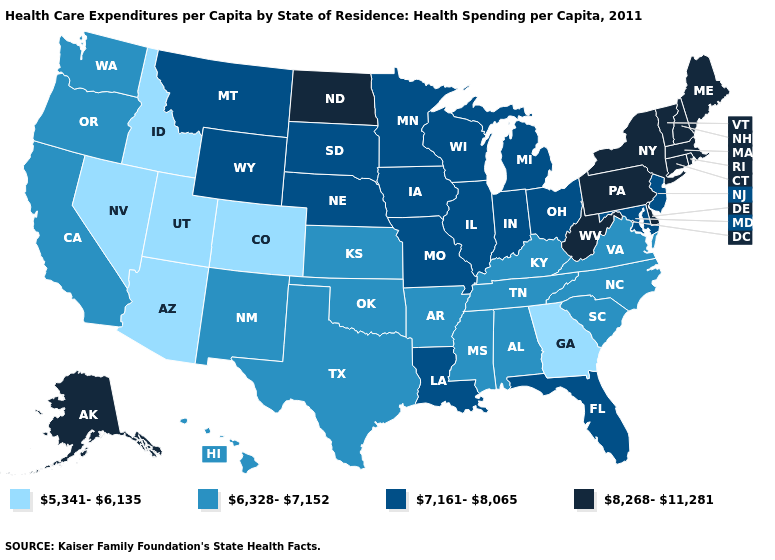What is the value of Ohio?
Short answer required. 7,161-8,065. Which states have the lowest value in the West?
Keep it brief. Arizona, Colorado, Idaho, Nevada, Utah. What is the highest value in the Northeast ?
Answer briefly. 8,268-11,281. What is the value of Missouri?
Give a very brief answer. 7,161-8,065. What is the value of Maine?
Write a very short answer. 8,268-11,281. Name the states that have a value in the range 6,328-7,152?
Keep it brief. Alabama, Arkansas, California, Hawaii, Kansas, Kentucky, Mississippi, New Mexico, North Carolina, Oklahoma, Oregon, South Carolina, Tennessee, Texas, Virginia, Washington. Name the states that have a value in the range 8,268-11,281?
Give a very brief answer. Alaska, Connecticut, Delaware, Maine, Massachusetts, New Hampshire, New York, North Dakota, Pennsylvania, Rhode Island, Vermont, West Virginia. What is the lowest value in states that border Wyoming?
Be succinct. 5,341-6,135. What is the value of Michigan?
Be succinct. 7,161-8,065. Does the map have missing data?
Answer briefly. No. How many symbols are there in the legend?
Concise answer only. 4. Does Texas have a lower value than North Carolina?
Quick response, please. No. Name the states that have a value in the range 5,341-6,135?
Quick response, please. Arizona, Colorado, Georgia, Idaho, Nevada, Utah. Does Ohio have the highest value in the USA?
Give a very brief answer. No. Name the states that have a value in the range 5,341-6,135?
Write a very short answer. Arizona, Colorado, Georgia, Idaho, Nevada, Utah. 